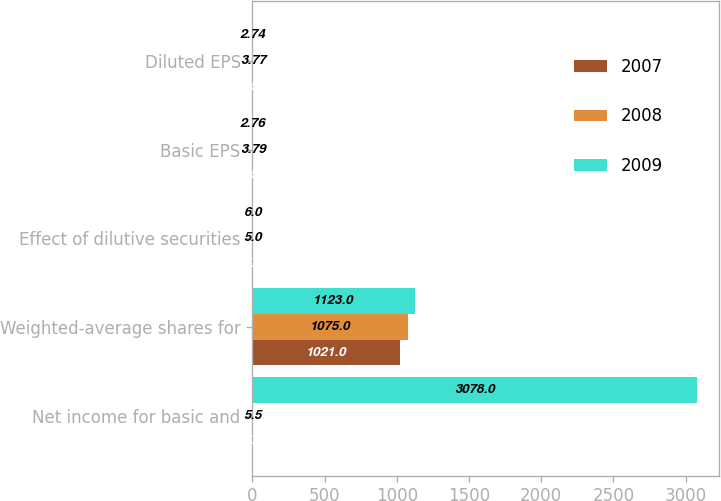<chart> <loc_0><loc_0><loc_500><loc_500><stacked_bar_chart><ecel><fcel>Net income for basic and<fcel>Weighted-average shares for<fcel>Effect of dilutive securities<fcel>Basic EPS<fcel>Diluted EPS<nl><fcel>2007<fcel>5.5<fcel>1021<fcel>5<fcel>4.53<fcel>4.51<nl><fcel>2008<fcel>5.5<fcel>1075<fcel>5<fcel>3.79<fcel>3.77<nl><fcel>2009<fcel>3078<fcel>1123<fcel>6<fcel>2.76<fcel>2.74<nl></chart> 